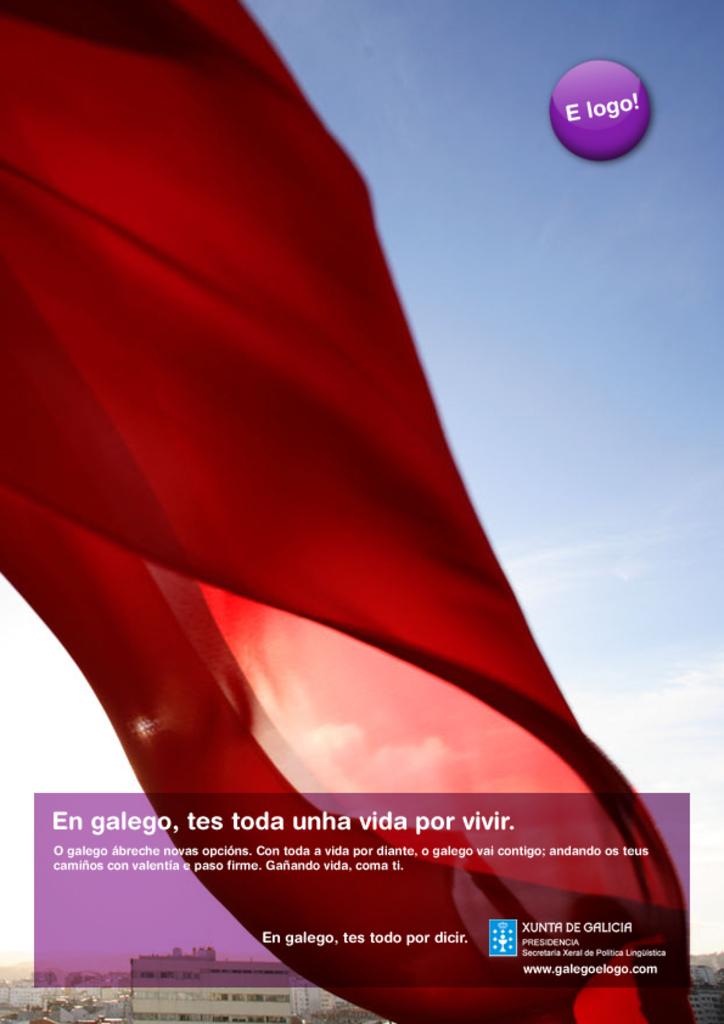What is the name of the website?
Provide a short and direct response. Www.galegoelogo.com. 